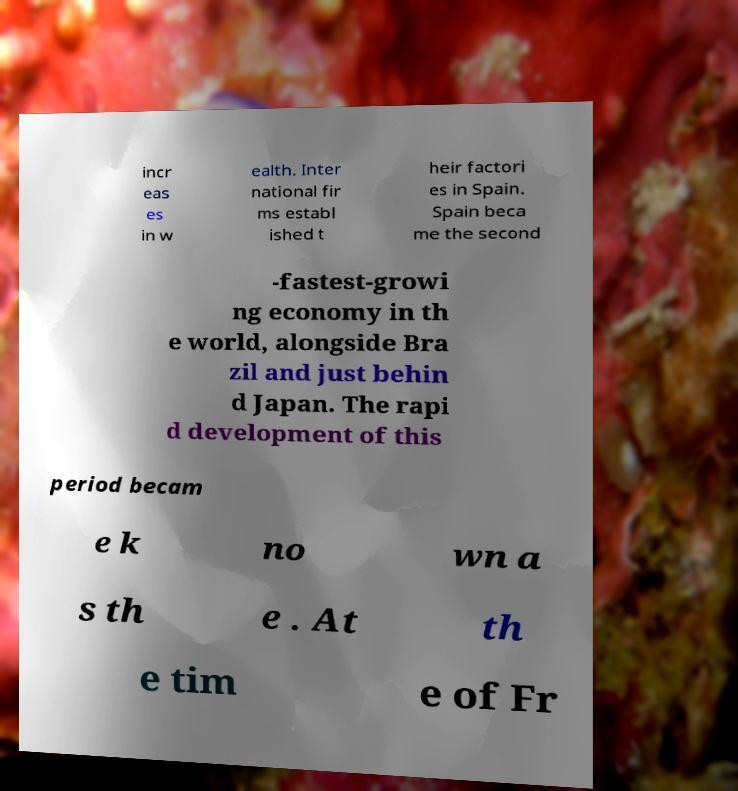Can you accurately transcribe the text from the provided image for me? incr eas es in w ealth. Inter national fir ms establ ished t heir factori es in Spain. Spain beca me the second -fastest-growi ng economy in th e world, alongside Bra zil and just behin d Japan. The rapi d development of this period becam e k no wn a s th e . At th e tim e of Fr 